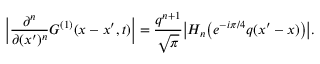<formula> <loc_0><loc_0><loc_500><loc_500>\left | \frac { \partial ^ { n } } { \partial ( x ^ { \prime } ) ^ { n } } G ^ { ( 1 ) } ( x - x ^ { \prime } , t ) \right | = \frac { q ^ { n + 1 } } { \sqrt { \pi } } \left | H _ { n } \left ( e ^ { - i \pi / 4 } q ( x ^ { \prime } - x ) \right ) \right | .</formula> 